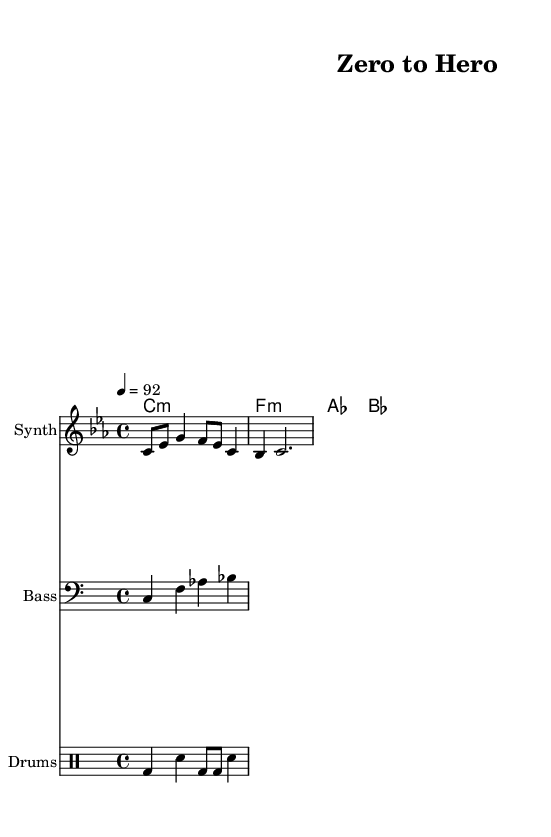What is the key signature of this music? The key signature is indicated at the beginning of the music sheet. Here, it shows one flat, which identifies it as C minor.
Answer: C minor What is the time signature of this piece? The time signature is shown at the beginning of the sheet music, which indicates how many beats are in a measure. In this case, it is 4/4, meaning there are four beats per measure, with a quarter note receiving one beat.
Answer: 4/4 What is the tempo marking of the piece? The tempo marking is found within the global settings, where it specifies the speed of the piece. Here, it states "4 = 92", meaning there are 92 beats per minute, with one quarter note being one beat.
Answer: 92 Which instrument is designated for the melody? The instrument for the melody is listed in the staff settings. The "Synth" label indicates the instrument that plays the melody in this hip hop piece.
Answer: Synth How many measures are in the melody section? The melody is notated in a linear fashion. Counting the measures shown in the piece, we see there is one complete measure plus another measure, making a total of two measures in this section.
Answer: 2 What is the chord in the first measure? The chords are indicated in the ChordNames section, where the first measure is labeled with "c1:m", which indicates a C minor chord played for one whole measure.
Answer: C minor 